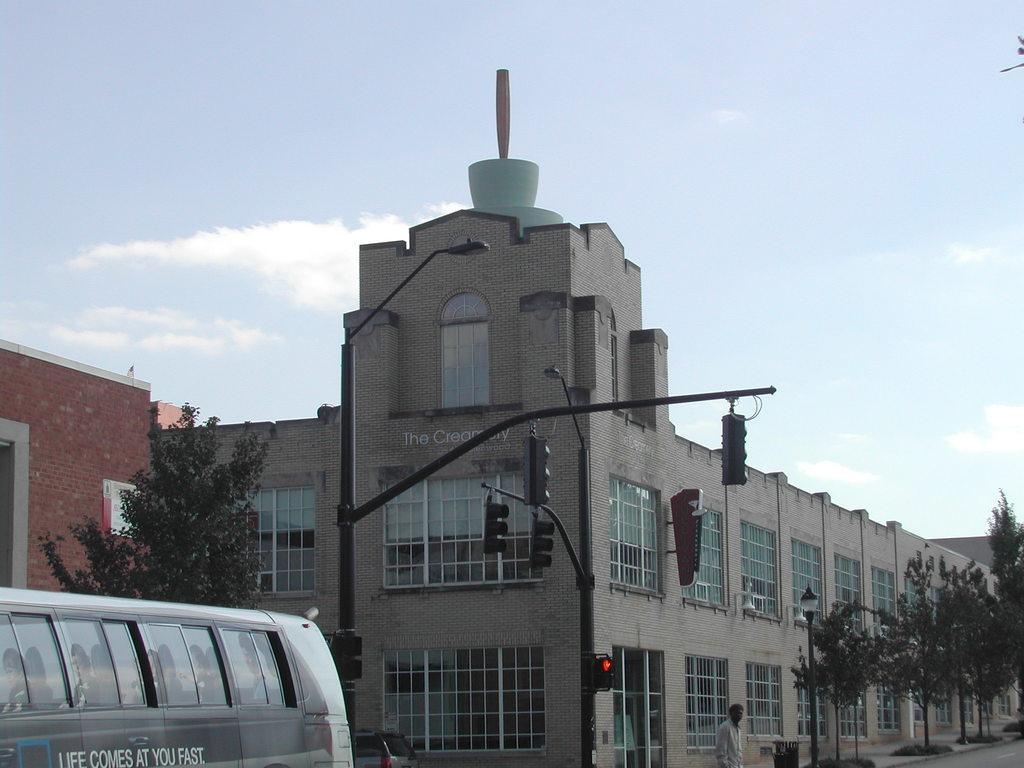Could you give a brief overview of what you see in this image? There is a person standing and we can see vehicles and we can see lights and traffic signals on poles. Background we can see building,wall,trees and sky. 